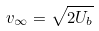<formula> <loc_0><loc_0><loc_500><loc_500>v _ { \infty } = \sqrt { 2 U _ { b } }</formula> 